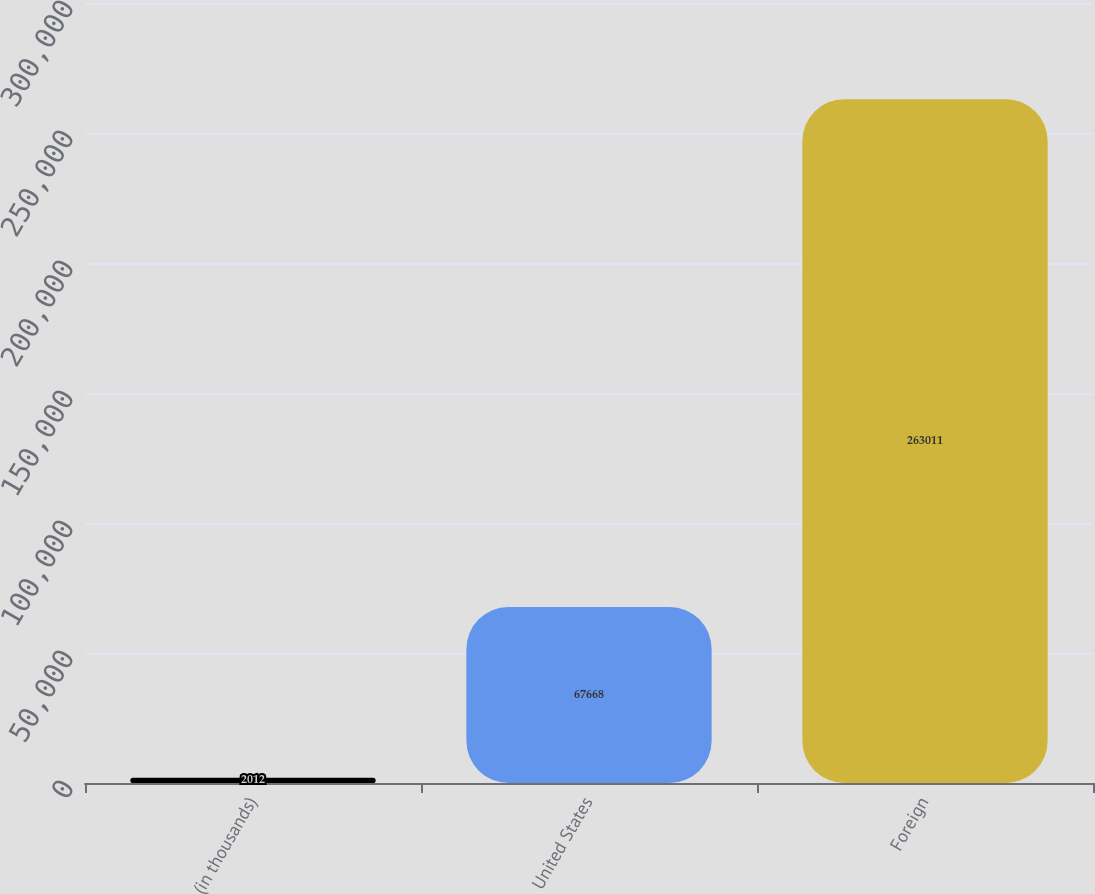Convert chart. <chart><loc_0><loc_0><loc_500><loc_500><bar_chart><fcel>(in thousands)<fcel>United States<fcel>Foreign<nl><fcel>2012<fcel>67668<fcel>263011<nl></chart> 